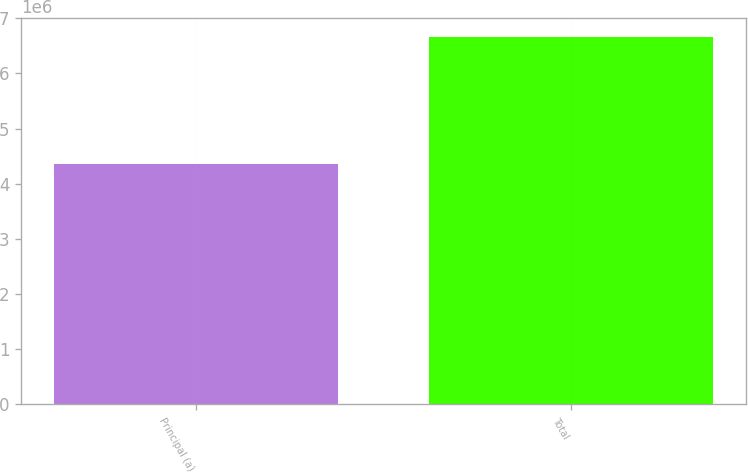Convert chart to OTSL. <chart><loc_0><loc_0><loc_500><loc_500><bar_chart><fcel>Principal (a)<fcel>Total<nl><fcel>4.36652e+06<fcel>6.66882e+06<nl></chart> 